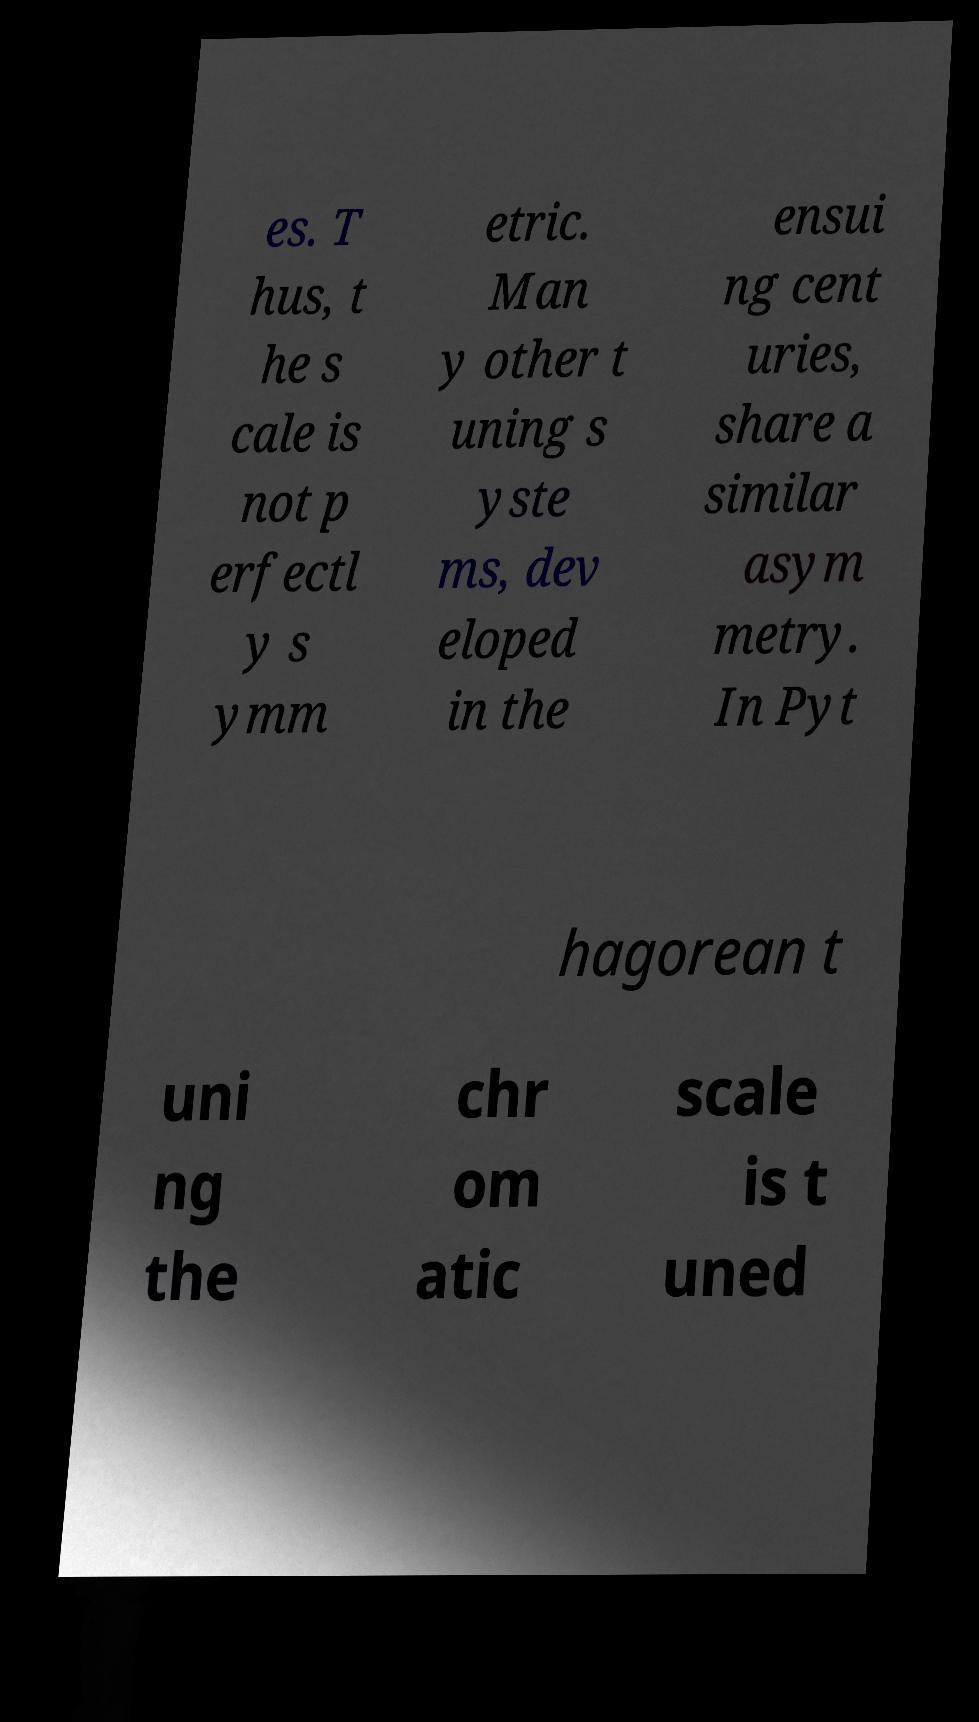Could you extract and type out the text from this image? es. T hus, t he s cale is not p erfectl y s ymm etric. Man y other t uning s yste ms, dev eloped in the ensui ng cent uries, share a similar asym metry. In Pyt hagorean t uni ng the chr om atic scale is t uned 